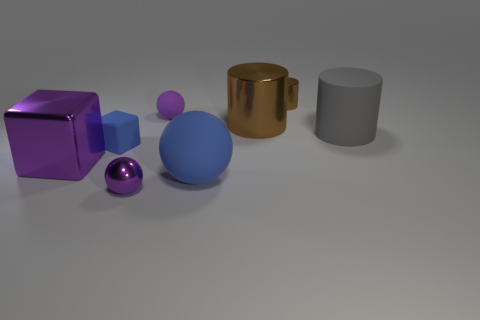How many things are either large objects behind the big blue matte sphere or brown rubber blocks?
Offer a very short reply. 3. Is the color of the large metallic cylinder the same as the matte block?
Offer a terse response. No. How many other objects are the same shape as the tiny blue matte thing?
Your answer should be very brief. 1. What number of brown objects are either matte balls or small cubes?
Offer a very short reply. 0. The big thing that is made of the same material as the blue ball is what color?
Offer a very short reply. Gray. Does the big cylinder behind the matte cylinder have the same material as the purple thing behind the gray matte cylinder?
Ensure brevity in your answer.  No. The rubber thing that is the same color as the tiny matte block is what size?
Your answer should be compact. Large. There is a tiny purple object right of the small purple shiny sphere; what is its material?
Offer a terse response. Rubber. Does the blue object behind the blue sphere have the same shape as the object that is in front of the blue matte sphere?
Your answer should be compact. No. There is a big ball that is the same color as the small rubber cube; what is its material?
Your answer should be very brief. Rubber. 